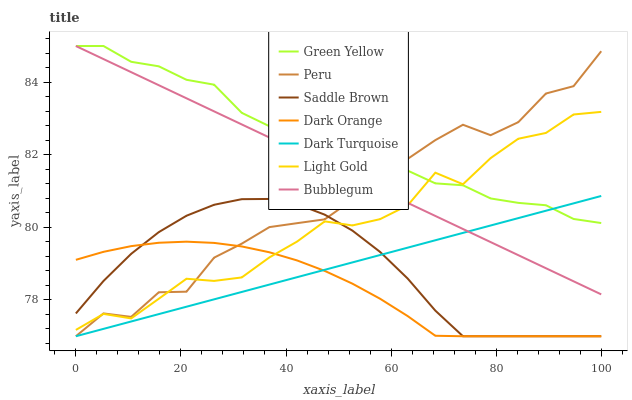Does Dark Orange have the minimum area under the curve?
Answer yes or no. Yes. Does Green Yellow have the maximum area under the curve?
Answer yes or no. Yes. Does Dark Turquoise have the minimum area under the curve?
Answer yes or no. No. Does Dark Turquoise have the maximum area under the curve?
Answer yes or no. No. Is Bubblegum the smoothest?
Answer yes or no. Yes. Is Peru the roughest?
Answer yes or no. Yes. Is Dark Turquoise the smoothest?
Answer yes or no. No. Is Dark Turquoise the roughest?
Answer yes or no. No. Does Dark Orange have the lowest value?
Answer yes or no. Yes. Does Bubblegum have the lowest value?
Answer yes or no. No. Does Green Yellow have the highest value?
Answer yes or no. Yes. Does Dark Turquoise have the highest value?
Answer yes or no. No. Is Saddle Brown less than Green Yellow?
Answer yes or no. Yes. Is Green Yellow greater than Dark Orange?
Answer yes or no. Yes. Does Peru intersect Dark Orange?
Answer yes or no. Yes. Is Peru less than Dark Orange?
Answer yes or no. No. Is Peru greater than Dark Orange?
Answer yes or no. No. Does Saddle Brown intersect Green Yellow?
Answer yes or no. No. 